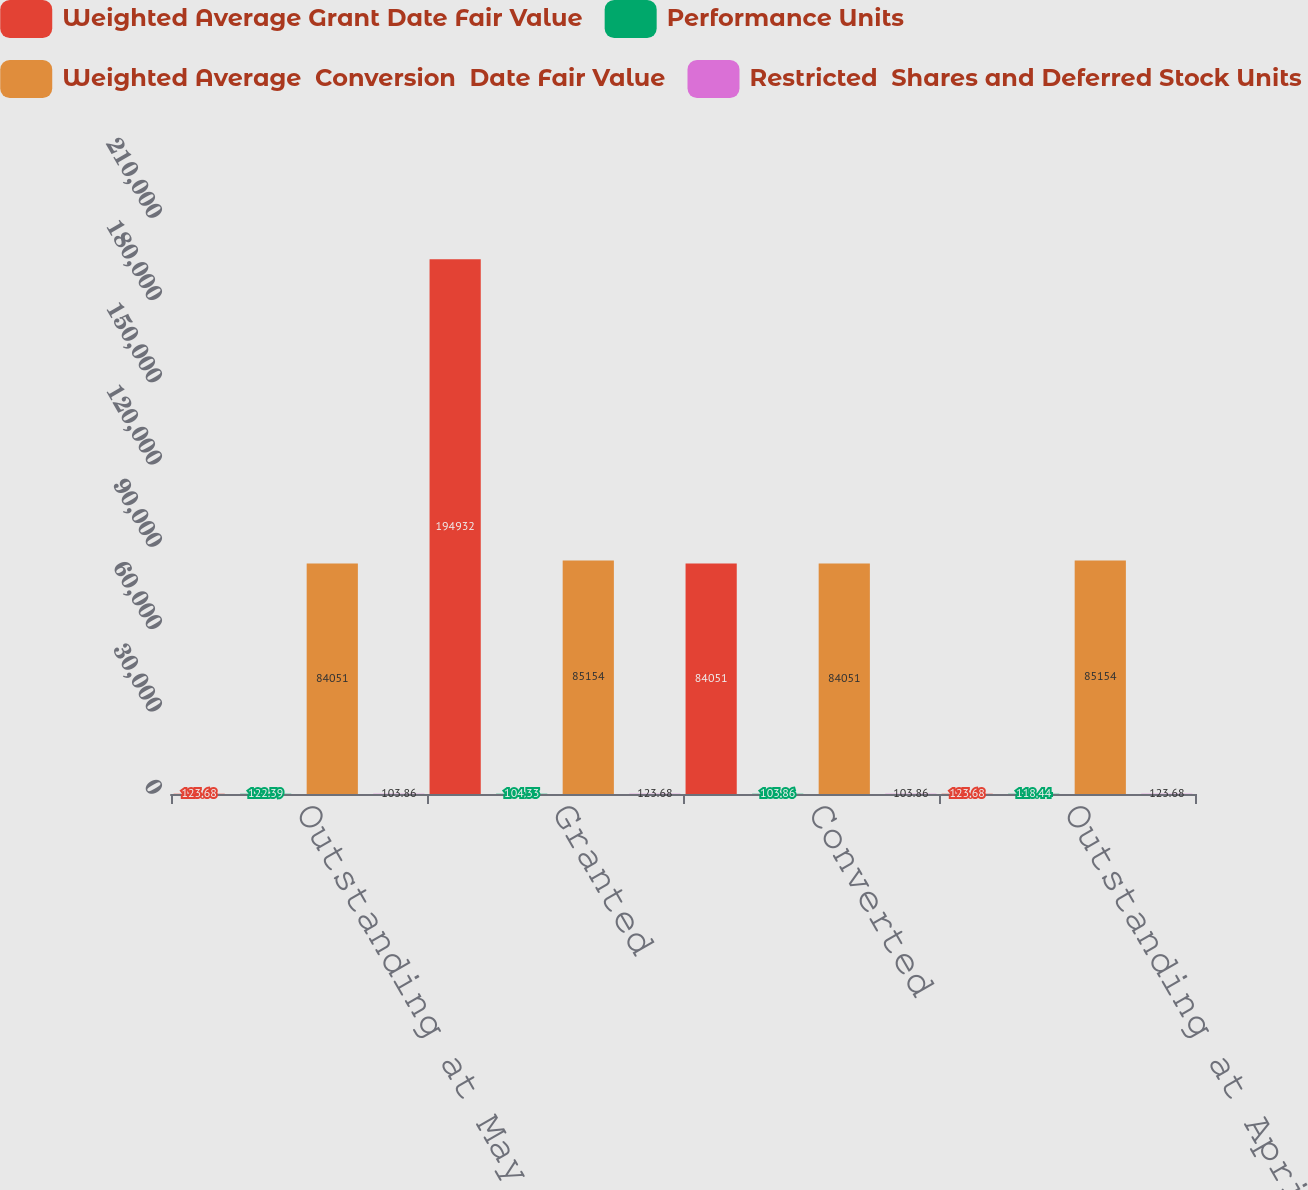Convert chart. <chart><loc_0><loc_0><loc_500><loc_500><stacked_bar_chart><ecel><fcel>Outstanding at May 1 2018<fcel>Granted<fcel>Converted<fcel>Outstanding at April 30 2019<nl><fcel>Weighted Average Grant Date Fair Value<fcel>123.68<fcel>194932<fcel>84051<fcel>123.68<nl><fcel>Performance Units<fcel>122.39<fcel>104.33<fcel>103.86<fcel>118.44<nl><fcel>Weighted Average  Conversion  Date Fair Value<fcel>84051<fcel>85154<fcel>84051<fcel>85154<nl><fcel>Restricted  Shares and Deferred Stock Units<fcel>103.86<fcel>123.68<fcel>103.86<fcel>123.68<nl></chart> 